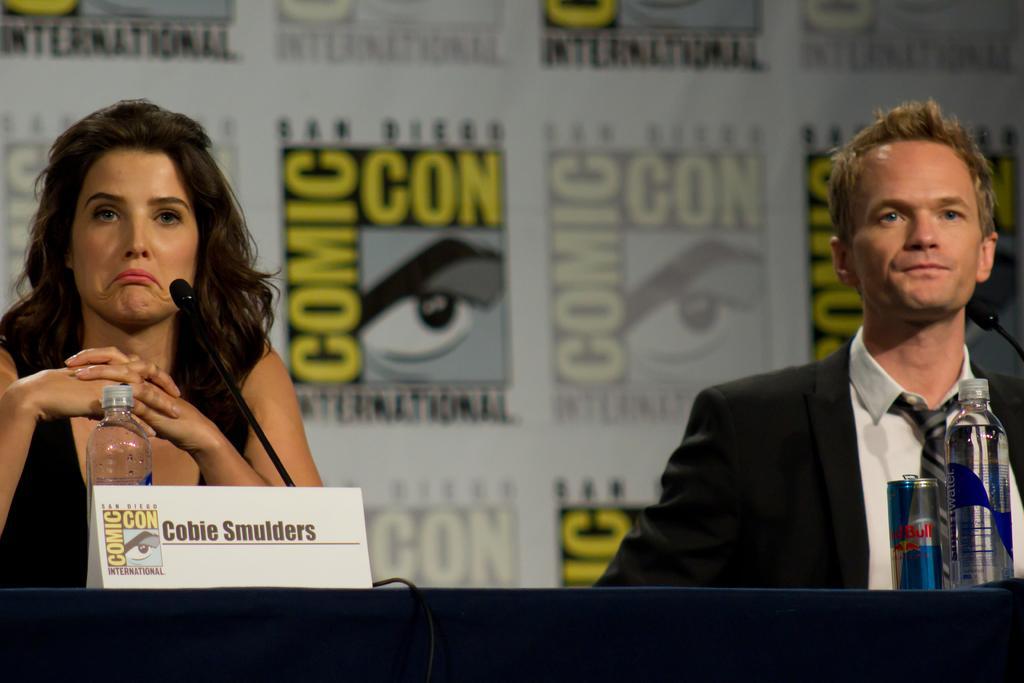Could you give a brief overview of what you see in this image? In this image, There is a black color table on that table there are some bottles and there is a can which is in blue color, In the left side there is a white color board on the table, There is a woman sitting and there is a microphone which is in black color, In the right side there is a man sitting on the chair, In the background there is a white color wall. 